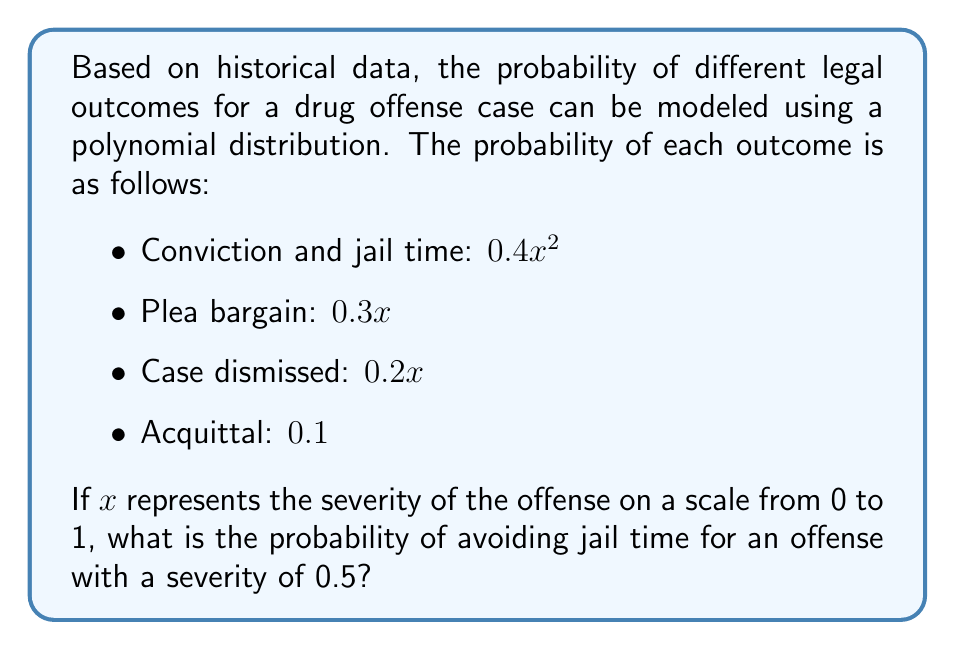Give your solution to this math problem. To solve this problem, we need to follow these steps:

1) First, we need to understand that the probability of avoiding jail time is the sum of the probabilities of plea bargain, case dismissal, and acquittal.

2) We're given that $x = 0.5$ (the severity of the offense).

3) Let's calculate each probability:

   Plea bargain: $0.3x = 0.3(0.5) = 0.15$
   Case dismissed: $0.2x = 0.2(0.5) = 0.1$
   Acquittal: $0.1$ (this is constant, regardless of $x$)

4) Now, we sum these probabilities:

   $P(\text{avoiding jail}) = 0.15 + 0.1 + 0.1 = 0.35$

5) To verify, we can check that all probabilities sum to 1:

   Conviction: $0.4(0.5)^2 = 0.1$
   Plea bargain: $0.15$
   Case dismissed: $0.1$
   Acquittal: $0.1$

   Total: $0.1 + 0.15 + 0.1 + 0.1 = 0.45$

   Indeed, all probabilities sum to 1, confirming our calculation.

Therefore, the probability of avoiding jail time for an offense with a severity of 0.5 is 0.35 or 35%.
Answer: 0.35 